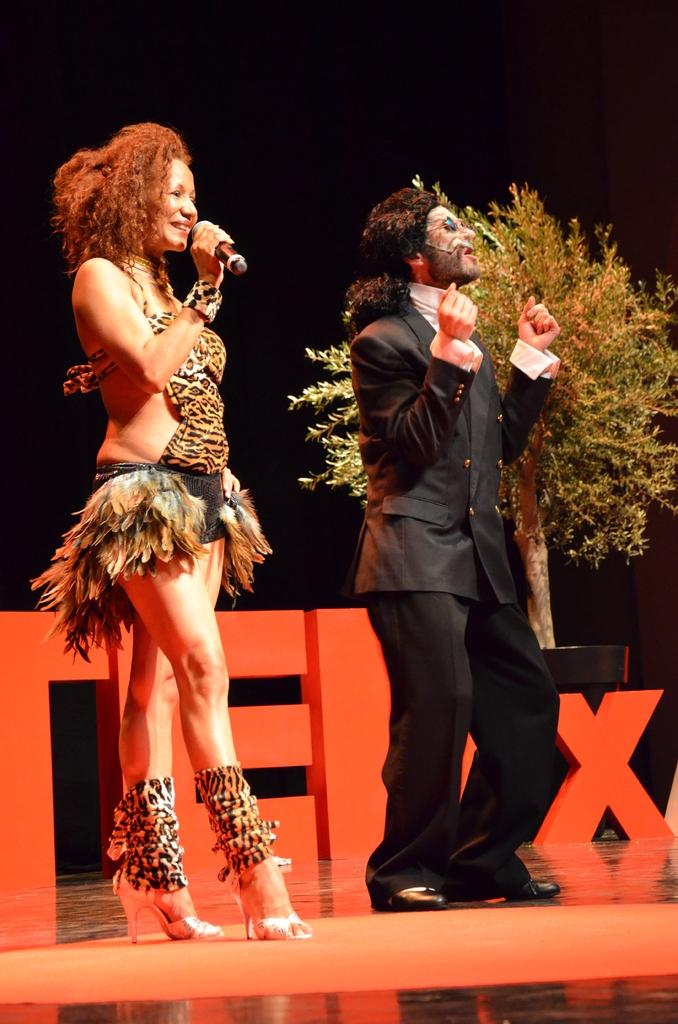Who can be seen in the image? There is a man and a woman in the image. What are the man and the woman wearing? Both the man and the woman are wearing different costumes. Where are they standing? They are standing on a stage. What else can be seen in the image? There are boards of letters and a tree visible in the image. How would you describe the overall lighting in the image? The overall view of the image is dark. Can you tell me how many hydrants are visible in the image? There are no hydrants present in the image. What type of feeling is being expressed by the tree in the image? Trees do not express feelings, and there is no indication of any emotions being conveyed in the image. 